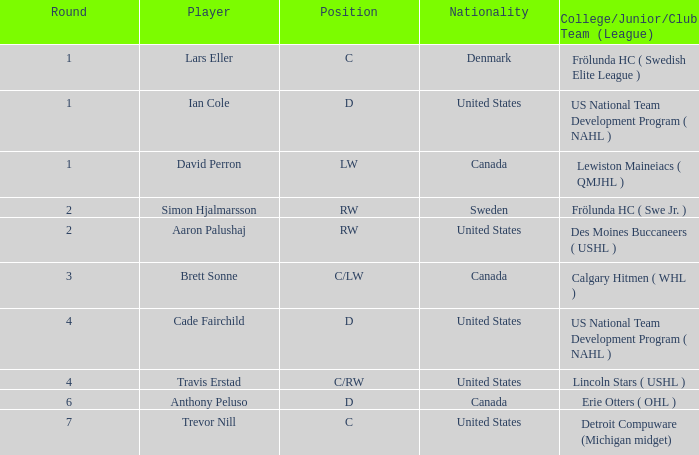Who is the player from Denmark who plays position c? Lars Eller. 